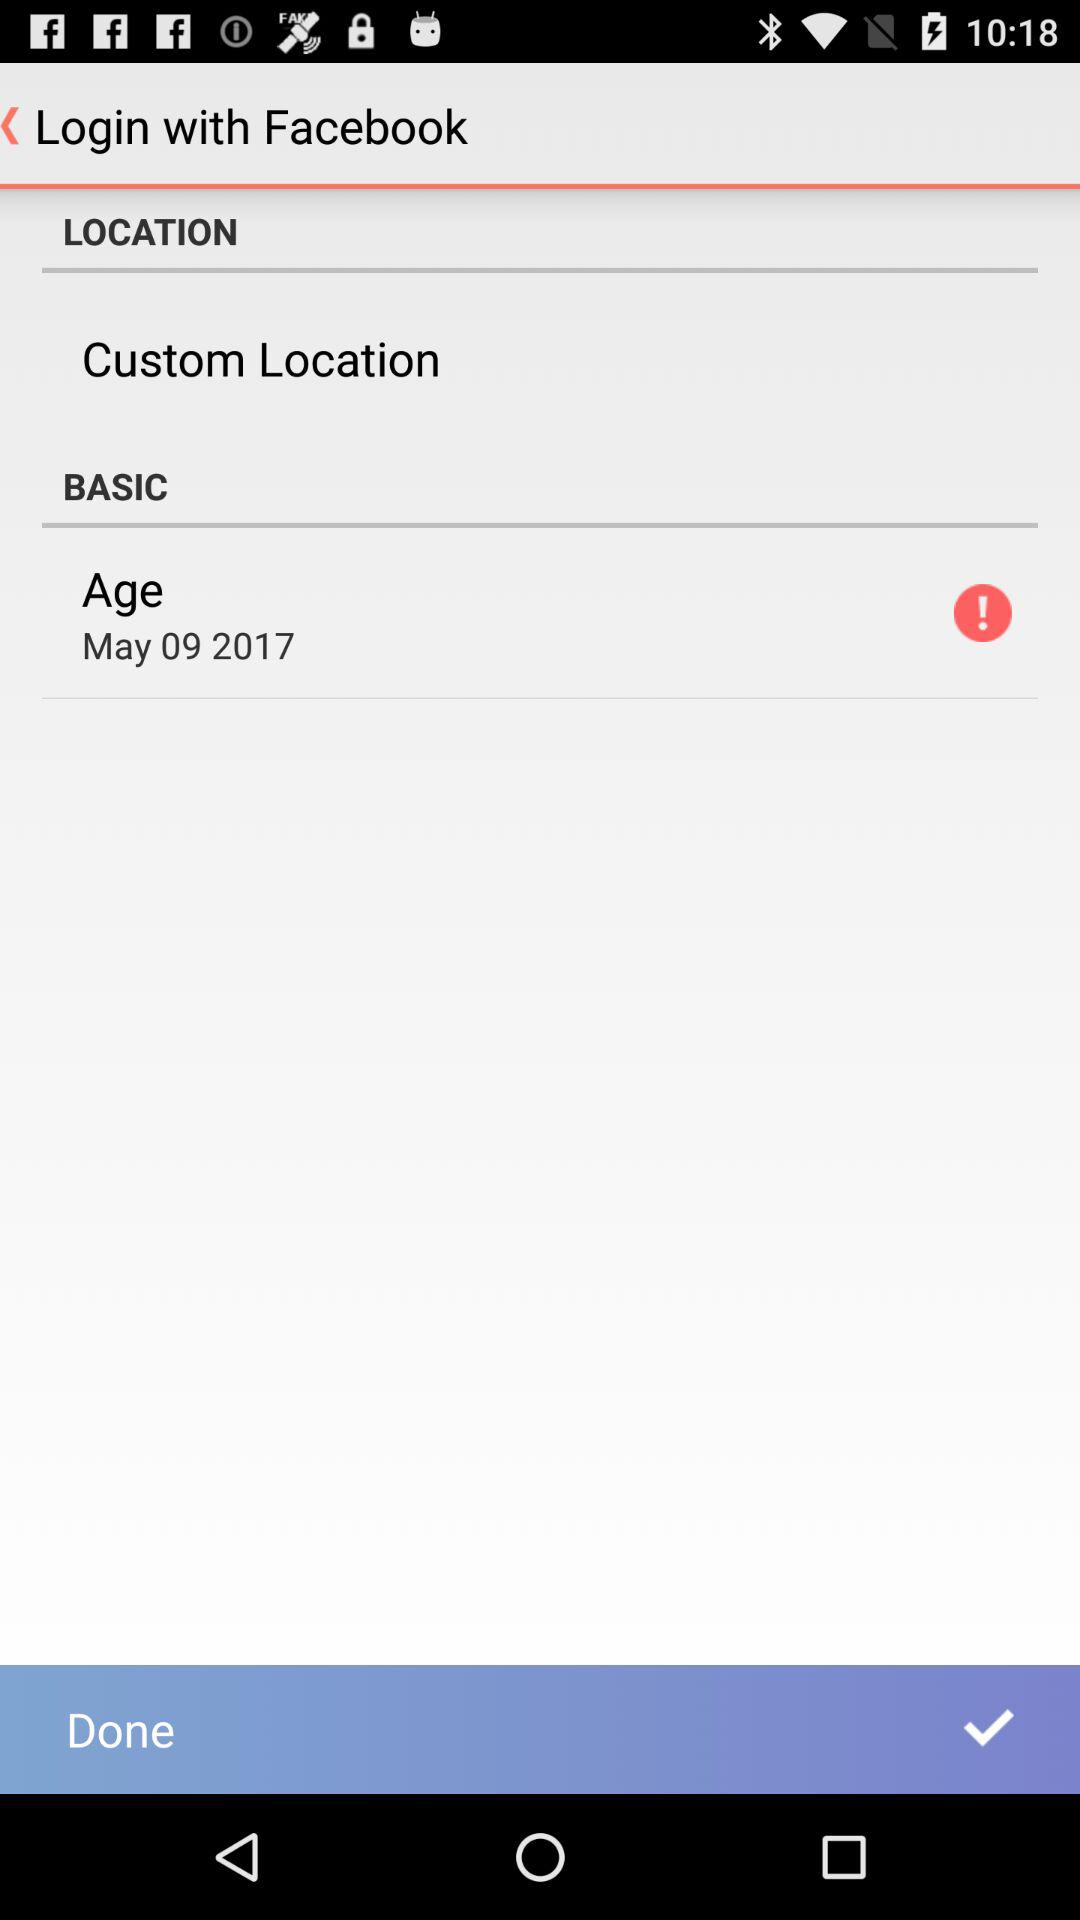What is the given birth date? The given birth date is May 9, 2017. 